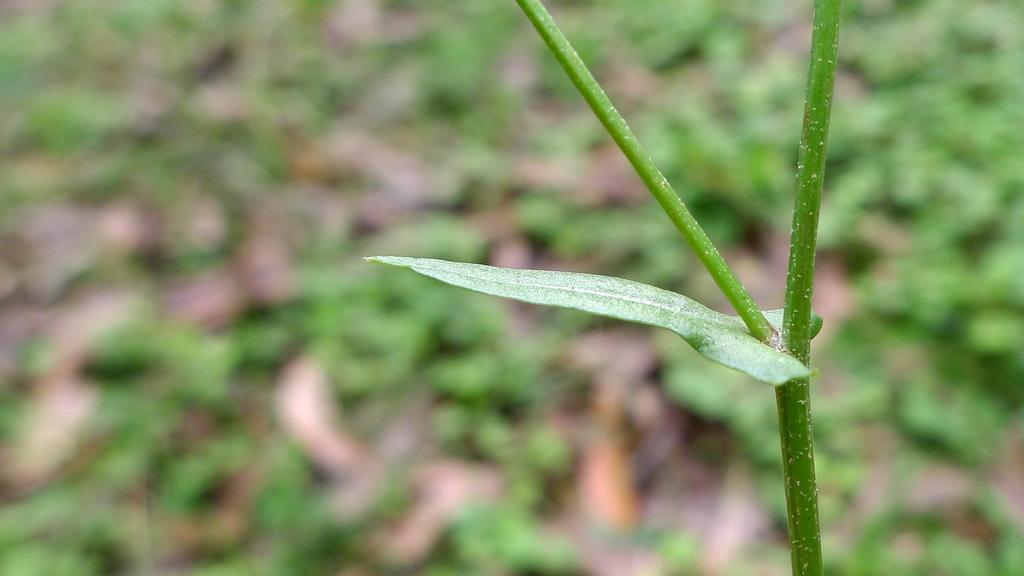What can be seen on the right side of the image? There is a stem on the right side of the image. What type of building is visible in the image? There is no building present in the image; it only features a stem. What discovery was made by the person in the image? There is no person or discovery present in the image; it only features a stem. 